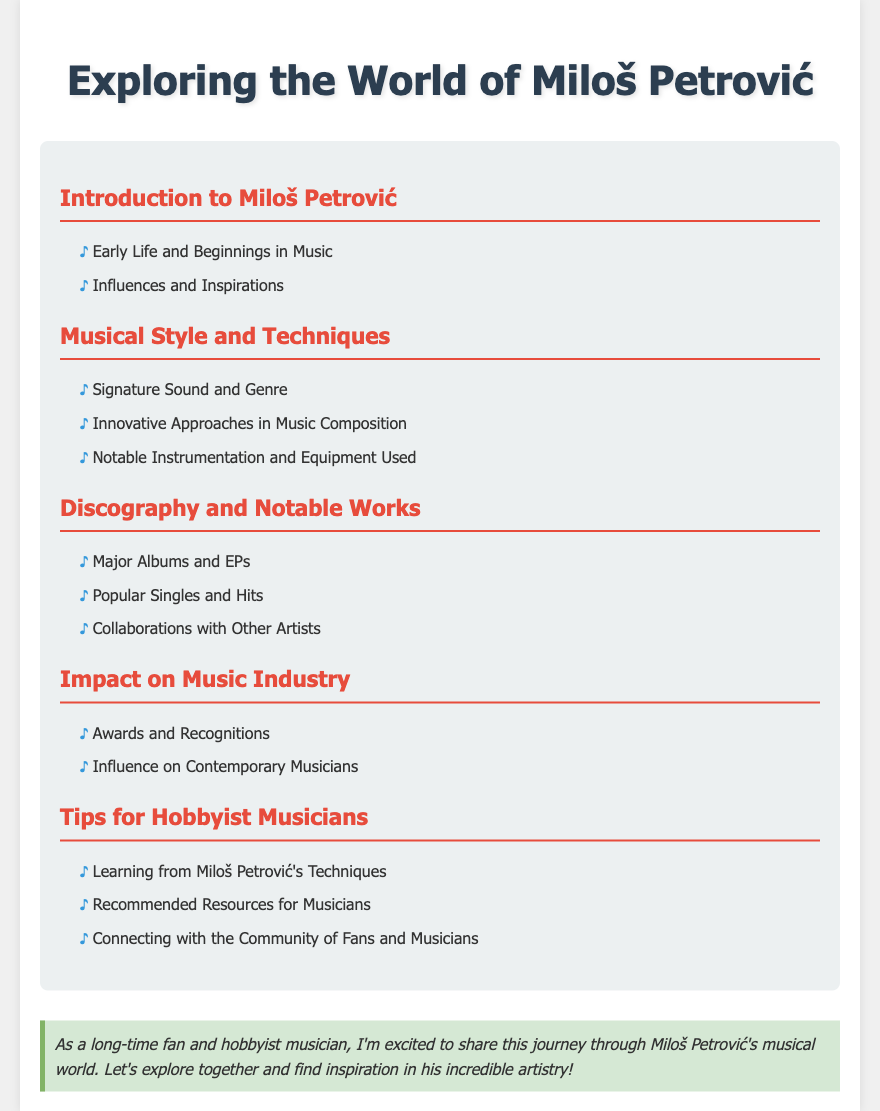What are the main sections in the Table of Contents? The main sections are listed as Introduction to Miloš Petrović, Musical Style and Techniques, Discography and Notable Works, Impact on Music Industry, and Tips for Hobbyist Musicians.
Answer: Introduction to Miloš Petrović, Musical Style and Techniques, Discography and Notable Works, Impact on Music Industry, Tips for Hobbyist Musicians Who is the subject of this document? The subject of this document is a musician, specifically highlighted in the title as Miloš Petrović.
Answer: Miloš Petrović What is a subtopic under Musical Style and Techniques? The subtopics include Signature Sound and Genre, Innovative Approaches in Music Composition, and Notable Instrumentation and Equipment Used.
Answer: Signature Sound and Genre How many subsections are there under Discography and Notable Works? The subsections under Discography and Notable Works include Major Albums and EPs, Popular Singles and Hits, and Collaborations with Other Artists, totaling three subsections.
Answer: 3 What is included in the Tips for Hobbyist Musicians? The subsections include Learning from Miloš Petrović's Techniques, Recommended Resources for Musicians, and Connecting with the Community of Fans and Musicians.
Answer: Learning from Miloš Petrović's Techniques, Recommended Resources for Musicians, Connecting with the Community of Fans and Musicians What color is used for the section headings? The section headings are styled with a deep red color, specifically the hex code associated with that shade.
Answer: #e74c3c What type of document is this? The document is a Table of Contents specifically designed to guide fans through various topics related to Miloš Petrović’s music.
Answer: Table of Contents How is the fan note styled in the document? The fan note has a background color of light green and includes an italic font style, providing an engaging note for the readers.
Answer: Background color of light green, italic font style What influences are mentioned in the document? The document includes a subsection titled Influences and Inspirations that hints at a deeper look into the musician's background.
Answer: Influences and Inspirations 